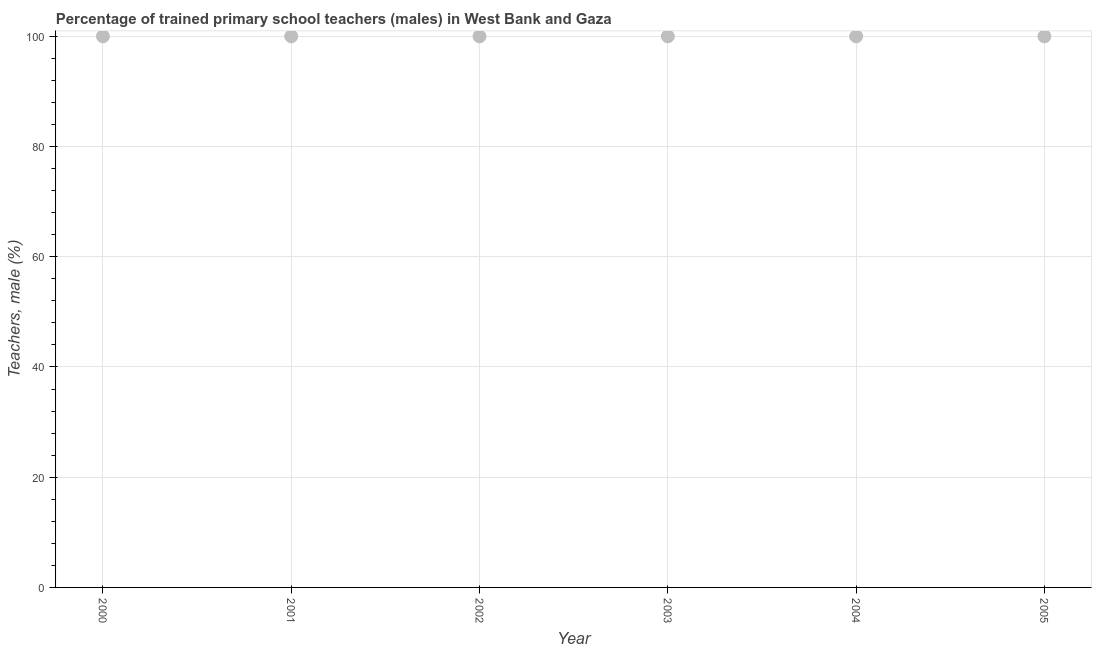What is the percentage of trained male teachers in 2002?
Make the answer very short. 100. Across all years, what is the maximum percentage of trained male teachers?
Keep it short and to the point. 100. Across all years, what is the minimum percentage of trained male teachers?
Offer a very short reply. 100. In which year was the percentage of trained male teachers minimum?
Your answer should be very brief. 2000. What is the sum of the percentage of trained male teachers?
Make the answer very short. 600. What is the difference between the percentage of trained male teachers in 2000 and 2003?
Your answer should be very brief. 0. What is the average percentage of trained male teachers per year?
Ensure brevity in your answer.  100. What is the median percentage of trained male teachers?
Offer a very short reply. 100. What is the ratio of the percentage of trained male teachers in 2001 to that in 2005?
Keep it short and to the point. 1. Is the percentage of trained male teachers in 2001 less than that in 2002?
Your answer should be compact. No. Is the sum of the percentage of trained male teachers in 2000 and 2003 greater than the maximum percentage of trained male teachers across all years?
Your answer should be compact. Yes. What is the difference between the highest and the lowest percentage of trained male teachers?
Your answer should be very brief. 0. Does the percentage of trained male teachers monotonically increase over the years?
Make the answer very short. No. How many dotlines are there?
Offer a terse response. 1. Are the values on the major ticks of Y-axis written in scientific E-notation?
Your response must be concise. No. Does the graph contain any zero values?
Keep it short and to the point. No. Does the graph contain grids?
Give a very brief answer. Yes. What is the title of the graph?
Provide a short and direct response. Percentage of trained primary school teachers (males) in West Bank and Gaza. What is the label or title of the Y-axis?
Your answer should be compact. Teachers, male (%). What is the Teachers, male (%) in 2000?
Keep it short and to the point. 100. What is the Teachers, male (%) in 2001?
Ensure brevity in your answer.  100. What is the Teachers, male (%) in 2002?
Give a very brief answer. 100. What is the Teachers, male (%) in 2003?
Give a very brief answer. 100. What is the Teachers, male (%) in 2004?
Your response must be concise. 100. What is the difference between the Teachers, male (%) in 2000 and 2002?
Provide a short and direct response. 0. What is the difference between the Teachers, male (%) in 2000 and 2003?
Ensure brevity in your answer.  0. What is the difference between the Teachers, male (%) in 2000 and 2005?
Ensure brevity in your answer.  0. What is the difference between the Teachers, male (%) in 2001 and 2004?
Your response must be concise. 0. What is the difference between the Teachers, male (%) in 2001 and 2005?
Provide a succinct answer. 0. What is the difference between the Teachers, male (%) in 2002 and 2004?
Keep it short and to the point. 0. What is the difference between the Teachers, male (%) in 2002 and 2005?
Your answer should be compact. 0. What is the difference between the Teachers, male (%) in 2003 and 2004?
Your answer should be compact. 0. What is the ratio of the Teachers, male (%) in 2000 to that in 2001?
Provide a short and direct response. 1. What is the ratio of the Teachers, male (%) in 2000 to that in 2005?
Keep it short and to the point. 1. What is the ratio of the Teachers, male (%) in 2001 to that in 2002?
Provide a short and direct response. 1. What is the ratio of the Teachers, male (%) in 2001 to that in 2004?
Ensure brevity in your answer.  1. What is the ratio of the Teachers, male (%) in 2001 to that in 2005?
Make the answer very short. 1. What is the ratio of the Teachers, male (%) in 2002 to that in 2004?
Ensure brevity in your answer.  1. What is the ratio of the Teachers, male (%) in 2003 to that in 2004?
Make the answer very short. 1. What is the ratio of the Teachers, male (%) in 2004 to that in 2005?
Make the answer very short. 1. 